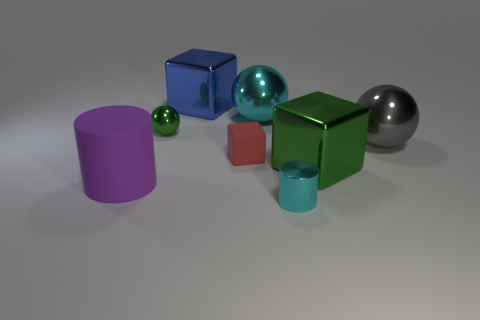Can you describe the texture of the objects in this scene? Sure, the scene presents a variety of textures. The purple cylinder and the green cube possess a matte finish, devoid of any reflective qualities, suggesting a possibly rough or satiny surface. The silver sphere, blue cube, and turquoise shiny ball all exhibit highly reflective surfaces, likely smooth to the touch, indicative of polished metal or glass materials. 